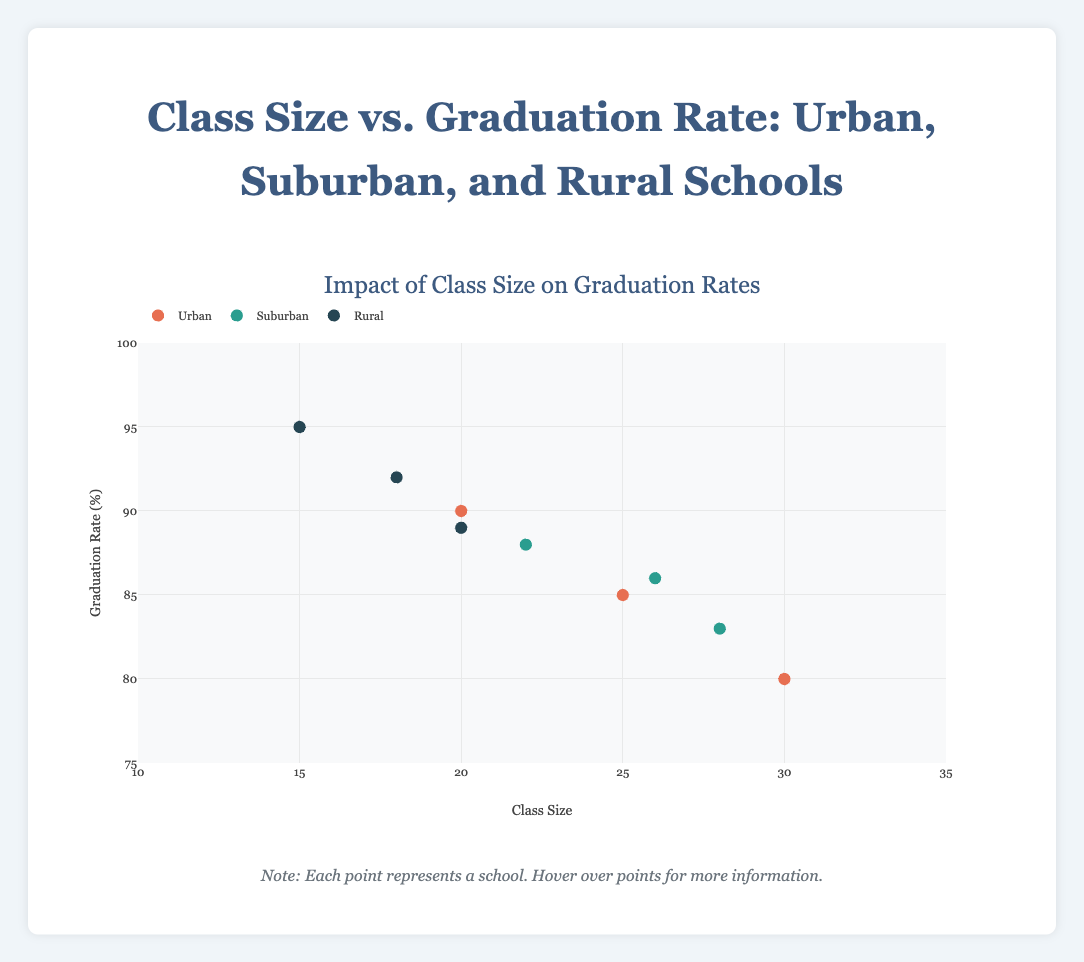What is the title of the figure? The title can be found at the top center of the figure in bold text.
Answer: "Class Size vs. Graduation Rate: Urban, Suburban, and Rural Schools" What is the range of the x-axis? The range of the x-axis can be found at the bottom of the figure labeled "Class Size" ranging from the minimum to maximum values.
Answer: 10 to 35 Which location type has the highest graduation rate overall and what is it? Look for the point with the highest position on the y-axis and identify the group by its color and label. The highest point is in the Rural group.
Answer: Rural, 95% What is the class size range for suburban schools? Observe the horizontal spread of the green points representing suburban schools. The values range from the minimum to maximum observed class sizes.
Answer: 22 to 28 Compare the average graduation rate of urban and rural schools. Which one is higher? Calculate the average graduation rates for each group by summing the rates and dividing by the number of schools in the group. Compare the two averages.
Answer: Rural What trend do you observe between class size and graduation rates in rural schools? Examine the cluster of blue points representing rural schools to see if there is an upward or downward trend or no clear pattern.
Answer: Decrease in graduation rate with increasing class size How many urban schools are shown in the plot? Count the number of red points representing urban schools.
Answer: 3 Which school has the lowest graduation rate and what is its class size? Identify the point with the lowest y-value and hover over it to see the tooltip, which will include the school’s name and class size.
Answer: Roosevelt High School, class size 30 Between urban and suburban schools, which group has the wider range of class sizes? Compare the horizontal spread of points for both groups to see which has a greater difference between the smallest and largest class sizes.
Answer: Urban Do any schools have the same class size but different graduation rates? Look for vertical alignment of points (same x-value) with different y-values.
Answer: Yes, Washington High School and Countryview High School have a class size of 20 but different graduation rates 